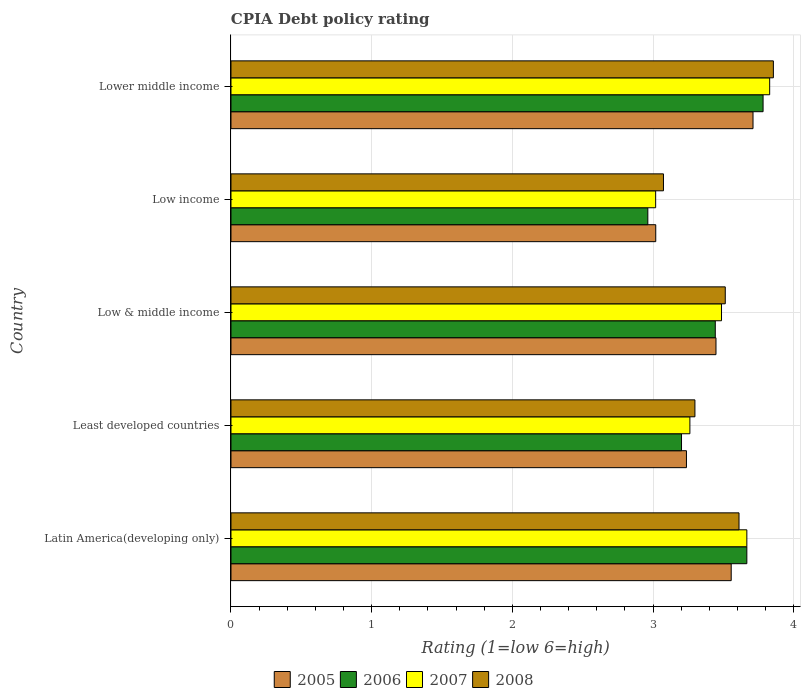Are the number of bars on each tick of the Y-axis equal?
Offer a very short reply. Yes. What is the label of the 2nd group of bars from the top?
Provide a short and direct response. Low income. In how many cases, is the number of bars for a given country not equal to the number of legend labels?
Give a very brief answer. 0. What is the CPIA rating in 2006 in Least developed countries?
Provide a succinct answer. 3.2. Across all countries, what is the maximum CPIA rating in 2006?
Your answer should be compact. 3.78. Across all countries, what is the minimum CPIA rating in 2006?
Provide a short and direct response. 2.96. In which country was the CPIA rating in 2008 maximum?
Provide a succinct answer. Lower middle income. In which country was the CPIA rating in 2006 minimum?
Your answer should be compact. Low income. What is the total CPIA rating in 2005 in the graph?
Give a very brief answer. 16.97. What is the difference between the CPIA rating in 2006 in Least developed countries and that in Lower middle income?
Offer a terse response. -0.58. What is the difference between the CPIA rating in 2008 in Latin America(developing only) and the CPIA rating in 2005 in Low income?
Give a very brief answer. 0.59. What is the average CPIA rating in 2005 per country?
Make the answer very short. 3.39. What is the difference between the CPIA rating in 2008 and CPIA rating in 2005 in Least developed countries?
Give a very brief answer. 0.06. What is the ratio of the CPIA rating in 2006 in Latin America(developing only) to that in Low income?
Keep it short and to the point. 1.24. Is the CPIA rating in 2006 in Least developed countries less than that in Lower middle income?
Your response must be concise. Yes. Is the difference between the CPIA rating in 2008 in Least developed countries and Low & middle income greater than the difference between the CPIA rating in 2005 in Least developed countries and Low & middle income?
Offer a terse response. No. What is the difference between the highest and the second highest CPIA rating in 2005?
Ensure brevity in your answer.  0.15. What is the difference between the highest and the lowest CPIA rating in 2006?
Your answer should be very brief. 0.82. In how many countries, is the CPIA rating in 2005 greater than the average CPIA rating in 2005 taken over all countries?
Offer a very short reply. 3. What does the 3rd bar from the bottom in Latin America(developing only) represents?
Ensure brevity in your answer.  2007. How many bars are there?
Your response must be concise. 20. Are all the bars in the graph horizontal?
Your response must be concise. Yes. What is the difference between two consecutive major ticks on the X-axis?
Keep it short and to the point. 1. Are the values on the major ticks of X-axis written in scientific E-notation?
Keep it short and to the point. No. How many legend labels are there?
Give a very brief answer. 4. How are the legend labels stacked?
Offer a very short reply. Horizontal. What is the title of the graph?
Your answer should be very brief. CPIA Debt policy rating. What is the label or title of the X-axis?
Make the answer very short. Rating (1=low 6=high). What is the label or title of the Y-axis?
Your answer should be compact. Country. What is the Rating (1=low 6=high) of 2005 in Latin America(developing only)?
Give a very brief answer. 3.56. What is the Rating (1=low 6=high) of 2006 in Latin America(developing only)?
Make the answer very short. 3.67. What is the Rating (1=low 6=high) of 2007 in Latin America(developing only)?
Your response must be concise. 3.67. What is the Rating (1=low 6=high) in 2008 in Latin America(developing only)?
Ensure brevity in your answer.  3.61. What is the Rating (1=low 6=high) of 2005 in Least developed countries?
Keep it short and to the point. 3.24. What is the Rating (1=low 6=high) in 2006 in Least developed countries?
Offer a terse response. 3.2. What is the Rating (1=low 6=high) of 2007 in Least developed countries?
Ensure brevity in your answer.  3.26. What is the Rating (1=low 6=high) in 2008 in Least developed countries?
Make the answer very short. 3.3. What is the Rating (1=low 6=high) in 2005 in Low & middle income?
Your answer should be very brief. 3.45. What is the Rating (1=low 6=high) in 2006 in Low & middle income?
Provide a succinct answer. 3.44. What is the Rating (1=low 6=high) in 2007 in Low & middle income?
Give a very brief answer. 3.49. What is the Rating (1=low 6=high) in 2008 in Low & middle income?
Ensure brevity in your answer.  3.51. What is the Rating (1=low 6=high) in 2005 in Low income?
Your answer should be very brief. 3.02. What is the Rating (1=low 6=high) in 2006 in Low income?
Your response must be concise. 2.96. What is the Rating (1=low 6=high) of 2007 in Low income?
Offer a very short reply. 3.02. What is the Rating (1=low 6=high) in 2008 in Low income?
Provide a succinct answer. 3.07. What is the Rating (1=low 6=high) of 2005 in Lower middle income?
Offer a terse response. 3.71. What is the Rating (1=low 6=high) in 2006 in Lower middle income?
Your answer should be very brief. 3.78. What is the Rating (1=low 6=high) in 2007 in Lower middle income?
Your answer should be very brief. 3.83. What is the Rating (1=low 6=high) in 2008 in Lower middle income?
Make the answer very short. 3.86. Across all countries, what is the maximum Rating (1=low 6=high) in 2005?
Provide a short and direct response. 3.71. Across all countries, what is the maximum Rating (1=low 6=high) of 2006?
Provide a succinct answer. 3.78. Across all countries, what is the maximum Rating (1=low 6=high) in 2007?
Offer a terse response. 3.83. Across all countries, what is the maximum Rating (1=low 6=high) in 2008?
Offer a very short reply. 3.86. Across all countries, what is the minimum Rating (1=low 6=high) in 2005?
Offer a very short reply. 3.02. Across all countries, what is the minimum Rating (1=low 6=high) of 2006?
Offer a terse response. 2.96. Across all countries, what is the minimum Rating (1=low 6=high) of 2007?
Offer a terse response. 3.02. Across all countries, what is the minimum Rating (1=low 6=high) of 2008?
Provide a short and direct response. 3.07. What is the total Rating (1=low 6=high) in 2005 in the graph?
Provide a short and direct response. 16.97. What is the total Rating (1=low 6=high) of 2006 in the graph?
Ensure brevity in your answer.  17.06. What is the total Rating (1=low 6=high) of 2007 in the graph?
Keep it short and to the point. 17.26. What is the total Rating (1=low 6=high) in 2008 in the graph?
Offer a very short reply. 17.35. What is the difference between the Rating (1=low 6=high) of 2005 in Latin America(developing only) and that in Least developed countries?
Offer a terse response. 0.32. What is the difference between the Rating (1=low 6=high) of 2006 in Latin America(developing only) and that in Least developed countries?
Your answer should be compact. 0.46. What is the difference between the Rating (1=low 6=high) in 2007 in Latin America(developing only) and that in Least developed countries?
Your answer should be very brief. 0.4. What is the difference between the Rating (1=low 6=high) of 2008 in Latin America(developing only) and that in Least developed countries?
Your response must be concise. 0.31. What is the difference between the Rating (1=low 6=high) in 2005 in Latin America(developing only) and that in Low & middle income?
Offer a terse response. 0.11. What is the difference between the Rating (1=low 6=high) in 2006 in Latin America(developing only) and that in Low & middle income?
Provide a short and direct response. 0.22. What is the difference between the Rating (1=low 6=high) in 2007 in Latin America(developing only) and that in Low & middle income?
Keep it short and to the point. 0.18. What is the difference between the Rating (1=low 6=high) in 2008 in Latin America(developing only) and that in Low & middle income?
Give a very brief answer. 0.1. What is the difference between the Rating (1=low 6=high) of 2005 in Latin America(developing only) and that in Low income?
Make the answer very short. 0.54. What is the difference between the Rating (1=low 6=high) of 2006 in Latin America(developing only) and that in Low income?
Your answer should be very brief. 0.7. What is the difference between the Rating (1=low 6=high) of 2007 in Latin America(developing only) and that in Low income?
Give a very brief answer. 0.65. What is the difference between the Rating (1=low 6=high) of 2008 in Latin America(developing only) and that in Low income?
Offer a very short reply. 0.54. What is the difference between the Rating (1=low 6=high) of 2005 in Latin America(developing only) and that in Lower middle income?
Provide a succinct answer. -0.15. What is the difference between the Rating (1=low 6=high) of 2006 in Latin America(developing only) and that in Lower middle income?
Provide a short and direct response. -0.12. What is the difference between the Rating (1=low 6=high) of 2007 in Latin America(developing only) and that in Lower middle income?
Give a very brief answer. -0.16. What is the difference between the Rating (1=low 6=high) in 2008 in Latin America(developing only) and that in Lower middle income?
Your answer should be very brief. -0.24. What is the difference between the Rating (1=low 6=high) in 2005 in Least developed countries and that in Low & middle income?
Give a very brief answer. -0.21. What is the difference between the Rating (1=low 6=high) in 2006 in Least developed countries and that in Low & middle income?
Provide a succinct answer. -0.24. What is the difference between the Rating (1=low 6=high) in 2007 in Least developed countries and that in Low & middle income?
Make the answer very short. -0.22. What is the difference between the Rating (1=low 6=high) in 2008 in Least developed countries and that in Low & middle income?
Ensure brevity in your answer.  -0.22. What is the difference between the Rating (1=low 6=high) in 2005 in Least developed countries and that in Low income?
Make the answer very short. 0.22. What is the difference between the Rating (1=low 6=high) in 2006 in Least developed countries and that in Low income?
Your answer should be compact. 0.24. What is the difference between the Rating (1=low 6=high) of 2007 in Least developed countries and that in Low income?
Offer a very short reply. 0.24. What is the difference between the Rating (1=low 6=high) of 2008 in Least developed countries and that in Low income?
Keep it short and to the point. 0.22. What is the difference between the Rating (1=low 6=high) of 2005 in Least developed countries and that in Lower middle income?
Ensure brevity in your answer.  -0.47. What is the difference between the Rating (1=low 6=high) in 2006 in Least developed countries and that in Lower middle income?
Your response must be concise. -0.58. What is the difference between the Rating (1=low 6=high) in 2007 in Least developed countries and that in Lower middle income?
Your answer should be compact. -0.57. What is the difference between the Rating (1=low 6=high) of 2008 in Least developed countries and that in Lower middle income?
Offer a very short reply. -0.56. What is the difference between the Rating (1=low 6=high) of 2005 in Low & middle income and that in Low income?
Give a very brief answer. 0.43. What is the difference between the Rating (1=low 6=high) of 2006 in Low & middle income and that in Low income?
Give a very brief answer. 0.48. What is the difference between the Rating (1=low 6=high) in 2007 in Low & middle income and that in Low income?
Offer a terse response. 0.47. What is the difference between the Rating (1=low 6=high) of 2008 in Low & middle income and that in Low income?
Give a very brief answer. 0.44. What is the difference between the Rating (1=low 6=high) of 2005 in Low & middle income and that in Lower middle income?
Offer a very short reply. -0.26. What is the difference between the Rating (1=low 6=high) in 2006 in Low & middle income and that in Lower middle income?
Your answer should be compact. -0.34. What is the difference between the Rating (1=low 6=high) in 2007 in Low & middle income and that in Lower middle income?
Keep it short and to the point. -0.34. What is the difference between the Rating (1=low 6=high) in 2008 in Low & middle income and that in Lower middle income?
Your answer should be compact. -0.34. What is the difference between the Rating (1=low 6=high) of 2005 in Low income and that in Lower middle income?
Make the answer very short. -0.69. What is the difference between the Rating (1=low 6=high) in 2006 in Low income and that in Lower middle income?
Your answer should be compact. -0.82. What is the difference between the Rating (1=low 6=high) of 2007 in Low income and that in Lower middle income?
Ensure brevity in your answer.  -0.81. What is the difference between the Rating (1=low 6=high) of 2008 in Low income and that in Lower middle income?
Make the answer very short. -0.78. What is the difference between the Rating (1=low 6=high) of 2005 in Latin America(developing only) and the Rating (1=low 6=high) of 2006 in Least developed countries?
Your response must be concise. 0.35. What is the difference between the Rating (1=low 6=high) in 2005 in Latin America(developing only) and the Rating (1=low 6=high) in 2007 in Least developed countries?
Your response must be concise. 0.29. What is the difference between the Rating (1=low 6=high) in 2005 in Latin America(developing only) and the Rating (1=low 6=high) in 2008 in Least developed countries?
Make the answer very short. 0.26. What is the difference between the Rating (1=low 6=high) in 2006 in Latin America(developing only) and the Rating (1=low 6=high) in 2007 in Least developed countries?
Your answer should be very brief. 0.4. What is the difference between the Rating (1=low 6=high) in 2006 in Latin America(developing only) and the Rating (1=low 6=high) in 2008 in Least developed countries?
Provide a short and direct response. 0.37. What is the difference between the Rating (1=low 6=high) in 2007 in Latin America(developing only) and the Rating (1=low 6=high) in 2008 in Least developed countries?
Your answer should be very brief. 0.37. What is the difference between the Rating (1=low 6=high) of 2005 in Latin America(developing only) and the Rating (1=low 6=high) of 2006 in Low & middle income?
Offer a very short reply. 0.11. What is the difference between the Rating (1=low 6=high) of 2005 in Latin America(developing only) and the Rating (1=low 6=high) of 2007 in Low & middle income?
Ensure brevity in your answer.  0.07. What is the difference between the Rating (1=low 6=high) in 2005 in Latin America(developing only) and the Rating (1=low 6=high) in 2008 in Low & middle income?
Offer a very short reply. 0.04. What is the difference between the Rating (1=low 6=high) in 2006 in Latin America(developing only) and the Rating (1=low 6=high) in 2007 in Low & middle income?
Provide a succinct answer. 0.18. What is the difference between the Rating (1=low 6=high) in 2006 in Latin America(developing only) and the Rating (1=low 6=high) in 2008 in Low & middle income?
Keep it short and to the point. 0.15. What is the difference between the Rating (1=low 6=high) in 2007 in Latin America(developing only) and the Rating (1=low 6=high) in 2008 in Low & middle income?
Provide a succinct answer. 0.15. What is the difference between the Rating (1=low 6=high) in 2005 in Latin America(developing only) and the Rating (1=low 6=high) in 2006 in Low income?
Your response must be concise. 0.59. What is the difference between the Rating (1=low 6=high) of 2005 in Latin America(developing only) and the Rating (1=low 6=high) of 2007 in Low income?
Keep it short and to the point. 0.54. What is the difference between the Rating (1=low 6=high) in 2005 in Latin America(developing only) and the Rating (1=low 6=high) in 2008 in Low income?
Offer a very short reply. 0.48. What is the difference between the Rating (1=low 6=high) of 2006 in Latin America(developing only) and the Rating (1=low 6=high) of 2007 in Low income?
Keep it short and to the point. 0.65. What is the difference between the Rating (1=low 6=high) of 2006 in Latin America(developing only) and the Rating (1=low 6=high) of 2008 in Low income?
Your answer should be compact. 0.59. What is the difference between the Rating (1=low 6=high) in 2007 in Latin America(developing only) and the Rating (1=low 6=high) in 2008 in Low income?
Provide a succinct answer. 0.59. What is the difference between the Rating (1=low 6=high) of 2005 in Latin America(developing only) and the Rating (1=low 6=high) of 2006 in Lower middle income?
Provide a short and direct response. -0.23. What is the difference between the Rating (1=low 6=high) of 2005 in Latin America(developing only) and the Rating (1=low 6=high) of 2007 in Lower middle income?
Your response must be concise. -0.27. What is the difference between the Rating (1=low 6=high) in 2005 in Latin America(developing only) and the Rating (1=low 6=high) in 2008 in Lower middle income?
Make the answer very short. -0.3. What is the difference between the Rating (1=low 6=high) of 2006 in Latin America(developing only) and the Rating (1=low 6=high) of 2007 in Lower middle income?
Your answer should be very brief. -0.16. What is the difference between the Rating (1=low 6=high) in 2006 in Latin America(developing only) and the Rating (1=low 6=high) in 2008 in Lower middle income?
Provide a succinct answer. -0.19. What is the difference between the Rating (1=low 6=high) of 2007 in Latin America(developing only) and the Rating (1=low 6=high) of 2008 in Lower middle income?
Provide a succinct answer. -0.19. What is the difference between the Rating (1=low 6=high) of 2005 in Least developed countries and the Rating (1=low 6=high) of 2006 in Low & middle income?
Your answer should be very brief. -0.2. What is the difference between the Rating (1=low 6=high) in 2005 in Least developed countries and the Rating (1=low 6=high) in 2007 in Low & middle income?
Your answer should be very brief. -0.25. What is the difference between the Rating (1=low 6=high) in 2005 in Least developed countries and the Rating (1=low 6=high) in 2008 in Low & middle income?
Your answer should be compact. -0.28. What is the difference between the Rating (1=low 6=high) in 2006 in Least developed countries and the Rating (1=low 6=high) in 2007 in Low & middle income?
Keep it short and to the point. -0.28. What is the difference between the Rating (1=low 6=high) in 2006 in Least developed countries and the Rating (1=low 6=high) in 2008 in Low & middle income?
Your answer should be very brief. -0.31. What is the difference between the Rating (1=low 6=high) in 2007 in Least developed countries and the Rating (1=low 6=high) in 2008 in Low & middle income?
Your response must be concise. -0.25. What is the difference between the Rating (1=low 6=high) of 2005 in Least developed countries and the Rating (1=low 6=high) of 2006 in Low income?
Provide a short and direct response. 0.27. What is the difference between the Rating (1=low 6=high) in 2005 in Least developed countries and the Rating (1=low 6=high) in 2007 in Low income?
Make the answer very short. 0.22. What is the difference between the Rating (1=low 6=high) of 2005 in Least developed countries and the Rating (1=low 6=high) of 2008 in Low income?
Offer a very short reply. 0.16. What is the difference between the Rating (1=low 6=high) of 2006 in Least developed countries and the Rating (1=low 6=high) of 2007 in Low income?
Your answer should be compact. 0.18. What is the difference between the Rating (1=low 6=high) in 2006 in Least developed countries and the Rating (1=low 6=high) in 2008 in Low income?
Your answer should be compact. 0.13. What is the difference between the Rating (1=low 6=high) of 2007 in Least developed countries and the Rating (1=low 6=high) of 2008 in Low income?
Offer a very short reply. 0.19. What is the difference between the Rating (1=low 6=high) of 2005 in Least developed countries and the Rating (1=low 6=high) of 2006 in Lower middle income?
Offer a terse response. -0.54. What is the difference between the Rating (1=low 6=high) in 2005 in Least developed countries and the Rating (1=low 6=high) in 2007 in Lower middle income?
Provide a succinct answer. -0.59. What is the difference between the Rating (1=low 6=high) in 2005 in Least developed countries and the Rating (1=low 6=high) in 2008 in Lower middle income?
Provide a short and direct response. -0.62. What is the difference between the Rating (1=low 6=high) in 2006 in Least developed countries and the Rating (1=low 6=high) in 2007 in Lower middle income?
Your response must be concise. -0.63. What is the difference between the Rating (1=low 6=high) in 2006 in Least developed countries and the Rating (1=low 6=high) in 2008 in Lower middle income?
Give a very brief answer. -0.65. What is the difference between the Rating (1=low 6=high) of 2007 in Least developed countries and the Rating (1=low 6=high) of 2008 in Lower middle income?
Keep it short and to the point. -0.59. What is the difference between the Rating (1=low 6=high) of 2005 in Low & middle income and the Rating (1=low 6=high) of 2006 in Low income?
Your answer should be compact. 0.48. What is the difference between the Rating (1=low 6=high) of 2005 in Low & middle income and the Rating (1=low 6=high) of 2007 in Low income?
Keep it short and to the point. 0.43. What is the difference between the Rating (1=low 6=high) in 2005 in Low & middle income and the Rating (1=low 6=high) in 2008 in Low income?
Ensure brevity in your answer.  0.37. What is the difference between the Rating (1=low 6=high) of 2006 in Low & middle income and the Rating (1=low 6=high) of 2007 in Low income?
Your response must be concise. 0.42. What is the difference between the Rating (1=low 6=high) in 2006 in Low & middle income and the Rating (1=low 6=high) in 2008 in Low income?
Give a very brief answer. 0.37. What is the difference between the Rating (1=low 6=high) of 2007 in Low & middle income and the Rating (1=low 6=high) of 2008 in Low income?
Provide a succinct answer. 0.41. What is the difference between the Rating (1=low 6=high) in 2005 in Low & middle income and the Rating (1=low 6=high) in 2006 in Lower middle income?
Ensure brevity in your answer.  -0.33. What is the difference between the Rating (1=low 6=high) in 2005 in Low & middle income and the Rating (1=low 6=high) in 2007 in Lower middle income?
Provide a succinct answer. -0.38. What is the difference between the Rating (1=low 6=high) of 2005 in Low & middle income and the Rating (1=low 6=high) of 2008 in Lower middle income?
Ensure brevity in your answer.  -0.41. What is the difference between the Rating (1=low 6=high) in 2006 in Low & middle income and the Rating (1=low 6=high) in 2007 in Lower middle income?
Offer a very short reply. -0.39. What is the difference between the Rating (1=low 6=high) in 2006 in Low & middle income and the Rating (1=low 6=high) in 2008 in Lower middle income?
Keep it short and to the point. -0.41. What is the difference between the Rating (1=low 6=high) of 2007 in Low & middle income and the Rating (1=low 6=high) of 2008 in Lower middle income?
Your answer should be compact. -0.37. What is the difference between the Rating (1=low 6=high) in 2005 in Low income and the Rating (1=low 6=high) in 2006 in Lower middle income?
Your answer should be very brief. -0.76. What is the difference between the Rating (1=low 6=high) in 2005 in Low income and the Rating (1=low 6=high) in 2007 in Lower middle income?
Provide a short and direct response. -0.81. What is the difference between the Rating (1=low 6=high) in 2005 in Low income and the Rating (1=low 6=high) in 2008 in Lower middle income?
Provide a short and direct response. -0.84. What is the difference between the Rating (1=low 6=high) of 2006 in Low income and the Rating (1=low 6=high) of 2007 in Lower middle income?
Keep it short and to the point. -0.87. What is the difference between the Rating (1=low 6=high) in 2006 in Low income and the Rating (1=low 6=high) in 2008 in Lower middle income?
Provide a succinct answer. -0.89. What is the difference between the Rating (1=low 6=high) of 2007 in Low income and the Rating (1=low 6=high) of 2008 in Lower middle income?
Your answer should be very brief. -0.84. What is the average Rating (1=low 6=high) in 2005 per country?
Provide a succinct answer. 3.39. What is the average Rating (1=low 6=high) in 2006 per country?
Ensure brevity in your answer.  3.41. What is the average Rating (1=low 6=high) of 2007 per country?
Your answer should be very brief. 3.45. What is the average Rating (1=low 6=high) in 2008 per country?
Ensure brevity in your answer.  3.47. What is the difference between the Rating (1=low 6=high) of 2005 and Rating (1=low 6=high) of 2006 in Latin America(developing only)?
Your answer should be very brief. -0.11. What is the difference between the Rating (1=low 6=high) in 2005 and Rating (1=low 6=high) in 2007 in Latin America(developing only)?
Offer a very short reply. -0.11. What is the difference between the Rating (1=low 6=high) in 2005 and Rating (1=low 6=high) in 2008 in Latin America(developing only)?
Ensure brevity in your answer.  -0.06. What is the difference between the Rating (1=low 6=high) of 2006 and Rating (1=low 6=high) of 2007 in Latin America(developing only)?
Your answer should be very brief. 0. What is the difference between the Rating (1=low 6=high) in 2006 and Rating (1=low 6=high) in 2008 in Latin America(developing only)?
Keep it short and to the point. 0.06. What is the difference between the Rating (1=low 6=high) of 2007 and Rating (1=low 6=high) of 2008 in Latin America(developing only)?
Your answer should be very brief. 0.06. What is the difference between the Rating (1=low 6=high) of 2005 and Rating (1=low 6=high) of 2006 in Least developed countries?
Ensure brevity in your answer.  0.04. What is the difference between the Rating (1=low 6=high) of 2005 and Rating (1=low 6=high) of 2007 in Least developed countries?
Your response must be concise. -0.02. What is the difference between the Rating (1=low 6=high) of 2005 and Rating (1=low 6=high) of 2008 in Least developed countries?
Give a very brief answer. -0.06. What is the difference between the Rating (1=low 6=high) in 2006 and Rating (1=low 6=high) in 2007 in Least developed countries?
Your answer should be compact. -0.06. What is the difference between the Rating (1=low 6=high) of 2006 and Rating (1=low 6=high) of 2008 in Least developed countries?
Offer a terse response. -0.1. What is the difference between the Rating (1=low 6=high) of 2007 and Rating (1=low 6=high) of 2008 in Least developed countries?
Provide a succinct answer. -0.04. What is the difference between the Rating (1=low 6=high) of 2005 and Rating (1=low 6=high) of 2006 in Low & middle income?
Give a very brief answer. 0.01. What is the difference between the Rating (1=low 6=high) in 2005 and Rating (1=low 6=high) in 2007 in Low & middle income?
Make the answer very short. -0.04. What is the difference between the Rating (1=low 6=high) in 2005 and Rating (1=low 6=high) in 2008 in Low & middle income?
Give a very brief answer. -0.07. What is the difference between the Rating (1=low 6=high) of 2006 and Rating (1=low 6=high) of 2007 in Low & middle income?
Offer a terse response. -0.04. What is the difference between the Rating (1=low 6=high) in 2006 and Rating (1=low 6=high) in 2008 in Low & middle income?
Your answer should be compact. -0.07. What is the difference between the Rating (1=low 6=high) in 2007 and Rating (1=low 6=high) in 2008 in Low & middle income?
Ensure brevity in your answer.  -0.03. What is the difference between the Rating (1=low 6=high) in 2005 and Rating (1=low 6=high) in 2006 in Low income?
Give a very brief answer. 0.06. What is the difference between the Rating (1=low 6=high) of 2005 and Rating (1=low 6=high) of 2007 in Low income?
Ensure brevity in your answer.  0. What is the difference between the Rating (1=low 6=high) in 2005 and Rating (1=low 6=high) in 2008 in Low income?
Provide a short and direct response. -0.05. What is the difference between the Rating (1=low 6=high) of 2006 and Rating (1=low 6=high) of 2007 in Low income?
Ensure brevity in your answer.  -0.06. What is the difference between the Rating (1=low 6=high) in 2006 and Rating (1=low 6=high) in 2008 in Low income?
Your response must be concise. -0.11. What is the difference between the Rating (1=low 6=high) of 2007 and Rating (1=low 6=high) of 2008 in Low income?
Give a very brief answer. -0.06. What is the difference between the Rating (1=low 6=high) of 2005 and Rating (1=low 6=high) of 2006 in Lower middle income?
Provide a succinct answer. -0.07. What is the difference between the Rating (1=low 6=high) of 2005 and Rating (1=low 6=high) of 2007 in Lower middle income?
Your answer should be very brief. -0.12. What is the difference between the Rating (1=low 6=high) of 2005 and Rating (1=low 6=high) of 2008 in Lower middle income?
Offer a terse response. -0.14. What is the difference between the Rating (1=low 6=high) in 2006 and Rating (1=low 6=high) in 2007 in Lower middle income?
Your answer should be very brief. -0.05. What is the difference between the Rating (1=low 6=high) in 2006 and Rating (1=low 6=high) in 2008 in Lower middle income?
Give a very brief answer. -0.07. What is the difference between the Rating (1=low 6=high) of 2007 and Rating (1=low 6=high) of 2008 in Lower middle income?
Ensure brevity in your answer.  -0.03. What is the ratio of the Rating (1=low 6=high) of 2005 in Latin America(developing only) to that in Least developed countries?
Your answer should be compact. 1.1. What is the ratio of the Rating (1=low 6=high) of 2006 in Latin America(developing only) to that in Least developed countries?
Provide a short and direct response. 1.15. What is the ratio of the Rating (1=low 6=high) in 2007 in Latin America(developing only) to that in Least developed countries?
Provide a succinct answer. 1.12. What is the ratio of the Rating (1=low 6=high) of 2008 in Latin America(developing only) to that in Least developed countries?
Offer a terse response. 1.1. What is the ratio of the Rating (1=low 6=high) in 2005 in Latin America(developing only) to that in Low & middle income?
Ensure brevity in your answer.  1.03. What is the ratio of the Rating (1=low 6=high) in 2006 in Latin America(developing only) to that in Low & middle income?
Your answer should be compact. 1.07. What is the ratio of the Rating (1=low 6=high) in 2007 in Latin America(developing only) to that in Low & middle income?
Offer a very short reply. 1.05. What is the ratio of the Rating (1=low 6=high) in 2008 in Latin America(developing only) to that in Low & middle income?
Your answer should be very brief. 1.03. What is the ratio of the Rating (1=low 6=high) of 2005 in Latin America(developing only) to that in Low income?
Provide a short and direct response. 1.18. What is the ratio of the Rating (1=low 6=high) of 2006 in Latin America(developing only) to that in Low income?
Make the answer very short. 1.24. What is the ratio of the Rating (1=low 6=high) in 2007 in Latin America(developing only) to that in Low income?
Provide a succinct answer. 1.21. What is the ratio of the Rating (1=low 6=high) of 2008 in Latin America(developing only) to that in Low income?
Keep it short and to the point. 1.17. What is the ratio of the Rating (1=low 6=high) of 2005 in Latin America(developing only) to that in Lower middle income?
Ensure brevity in your answer.  0.96. What is the ratio of the Rating (1=low 6=high) in 2006 in Latin America(developing only) to that in Lower middle income?
Ensure brevity in your answer.  0.97. What is the ratio of the Rating (1=low 6=high) in 2007 in Latin America(developing only) to that in Lower middle income?
Your answer should be compact. 0.96. What is the ratio of the Rating (1=low 6=high) in 2008 in Latin America(developing only) to that in Lower middle income?
Ensure brevity in your answer.  0.94. What is the ratio of the Rating (1=low 6=high) of 2005 in Least developed countries to that in Low & middle income?
Provide a succinct answer. 0.94. What is the ratio of the Rating (1=low 6=high) of 2006 in Least developed countries to that in Low & middle income?
Your answer should be very brief. 0.93. What is the ratio of the Rating (1=low 6=high) in 2007 in Least developed countries to that in Low & middle income?
Your answer should be very brief. 0.94. What is the ratio of the Rating (1=low 6=high) of 2008 in Least developed countries to that in Low & middle income?
Offer a very short reply. 0.94. What is the ratio of the Rating (1=low 6=high) of 2005 in Least developed countries to that in Low income?
Make the answer very short. 1.07. What is the ratio of the Rating (1=low 6=high) in 2006 in Least developed countries to that in Low income?
Your response must be concise. 1.08. What is the ratio of the Rating (1=low 6=high) in 2007 in Least developed countries to that in Low income?
Your answer should be very brief. 1.08. What is the ratio of the Rating (1=low 6=high) in 2008 in Least developed countries to that in Low income?
Your answer should be compact. 1.07. What is the ratio of the Rating (1=low 6=high) in 2005 in Least developed countries to that in Lower middle income?
Provide a short and direct response. 0.87. What is the ratio of the Rating (1=low 6=high) in 2006 in Least developed countries to that in Lower middle income?
Provide a short and direct response. 0.85. What is the ratio of the Rating (1=low 6=high) in 2007 in Least developed countries to that in Lower middle income?
Offer a very short reply. 0.85. What is the ratio of the Rating (1=low 6=high) in 2008 in Least developed countries to that in Lower middle income?
Make the answer very short. 0.86. What is the ratio of the Rating (1=low 6=high) in 2005 in Low & middle income to that in Low income?
Provide a short and direct response. 1.14. What is the ratio of the Rating (1=low 6=high) in 2006 in Low & middle income to that in Low income?
Offer a very short reply. 1.16. What is the ratio of the Rating (1=low 6=high) in 2007 in Low & middle income to that in Low income?
Offer a very short reply. 1.16. What is the ratio of the Rating (1=low 6=high) of 2008 in Low & middle income to that in Low income?
Make the answer very short. 1.14. What is the ratio of the Rating (1=low 6=high) in 2005 in Low & middle income to that in Lower middle income?
Your response must be concise. 0.93. What is the ratio of the Rating (1=low 6=high) of 2006 in Low & middle income to that in Lower middle income?
Your response must be concise. 0.91. What is the ratio of the Rating (1=low 6=high) of 2007 in Low & middle income to that in Lower middle income?
Your answer should be very brief. 0.91. What is the ratio of the Rating (1=low 6=high) in 2008 in Low & middle income to that in Lower middle income?
Provide a succinct answer. 0.91. What is the ratio of the Rating (1=low 6=high) of 2005 in Low income to that in Lower middle income?
Your answer should be compact. 0.81. What is the ratio of the Rating (1=low 6=high) of 2006 in Low income to that in Lower middle income?
Provide a succinct answer. 0.78. What is the ratio of the Rating (1=low 6=high) of 2007 in Low income to that in Lower middle income?
Your answer should be compact. 0.79. What is the ratio of the Rating (1=low 6=high) in 2008 in Low income to that in Lower middle income?
Ensure brevity in your answer.  0.8. What is the difference between the highest and the second highest Rating (1=low 6=high) of 2005?
Your answer should be compact. 0.15. What is the difference between the highest and the second highest Rating (1=low 6=high) in 2006?
Offer a terse response. 0.12. What is the difference between the highest and the second highest Rating (1=low 6=high) of 2007?
Ensure brevity in your answer.  0.16. What is the difference between the highest and the second highest Rating (1=low 6=high) in 2008?
Offer a terse response. 0.24. What is the difference between the highest and the lowest Rating (1=low 6=high) in 2005?
Ensure brevity in your answer.  0.69. What is the difference between the highest and the lowest Rating (1=low 6=high) in 2006?
Provide a succinct answer. 0.82. What is the difference between the highest and the lowest Rating (1=low 6=high) of 2007?
Keep it short and to the point. 0.81. What is the difference between the highest and the lowest Rating (1=low 6=high) in 2008?
Your answer should be compact. 0.78. 